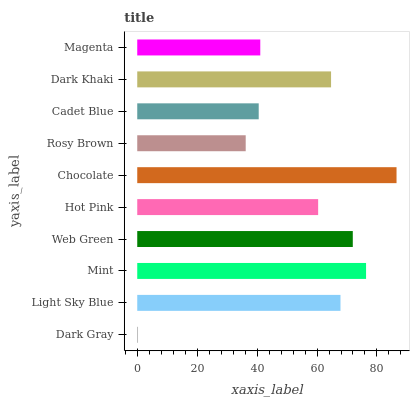Is Dark Gray the minimum?
Answer yes or no. Yes. Is Chocolate the maximum?
Answer yes or no. Yes. Is Light Sky Blue the minimum?
Answer yes or no. No. Is Light Sky Blue the maximum?
Answer yes or no. No. Is Light Sky Blue greater than Dark Gray?
Answer yes or no. Yes. Is Dark Gray less than Light Sky Blue?
Answer yes or no. Yes. Is Dark Gray greater than Light Sky Blue?
Answer yes or no. No. Is Light Sky Blue less than Dark Gray?
Answer yes or no. No. Is Dark Khaki the high median?
Answer yes or no. Yes. Is Hot Pink the low median?
Answer yes or no. Yes. Is Dark Gray the high median?
Answer yes or no. No. Is Dark Gray the low median?
Answer yes or no. No. 